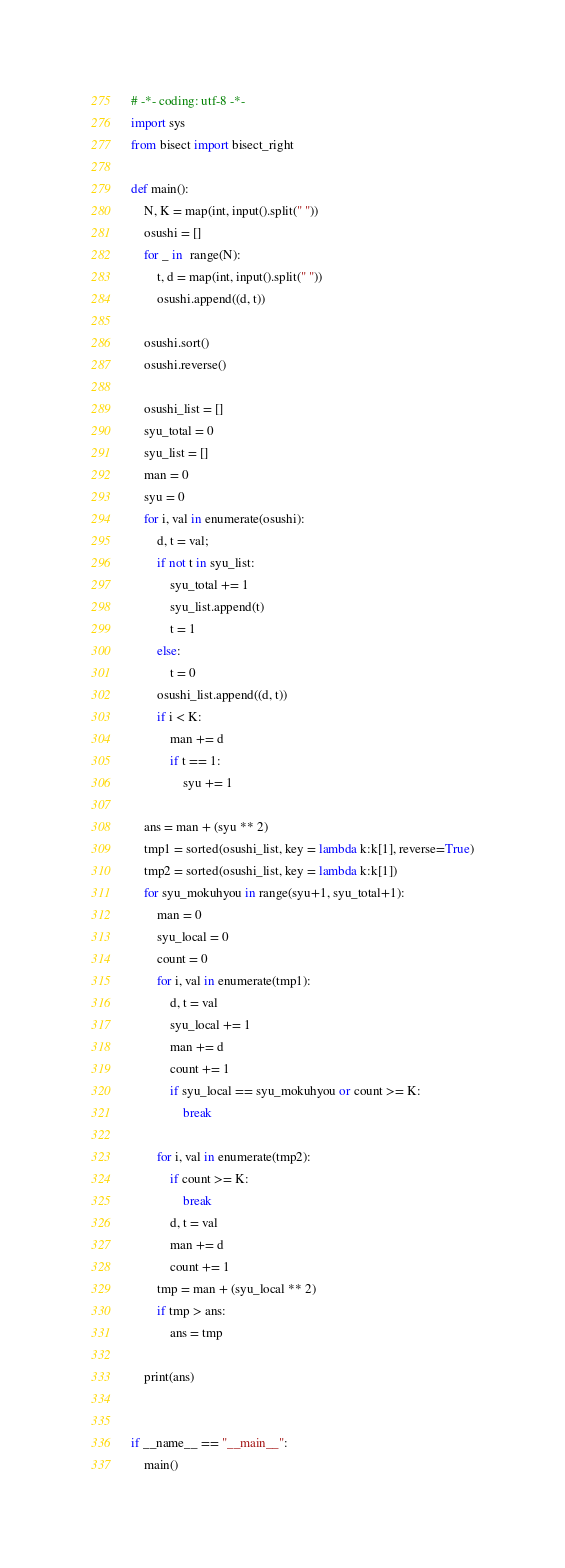<code> <loc_0><loc_0><loc_500><loc_500><_Python_># -*- coding: utf-8 -*-
import sys
from bisect import bisect_right

def main():
	N, K = map(int, input().split(" "))
	osushi = []
	for _ in  range(N):
		t, d = map(int, input().split(" "))
		osushi.append((d, t))
		
	osushi.sort()
	osushi.reverse()
	
	osushi_list = []
	syu_total = 0
	syu_list = []
	man = 0
	syu = 0
	for i, val in enumerate(osushi):
		d, t = val;
		if not t in syu_list:
			syu_total += 1
			syu_list.append(t)
			t = 1
		else:
			t = 0
		osushi_list.append((d, t))
		if i < K:
			man += d
			if t == 1:
				syu += 1
	
	ans = man + (syu ** 2)
	tmp1 = sorted(osushi_list, key = lambda k:k[1], reverse=True)
	tmp2 = sorted(osushi_list, key = lambda k:k[1])
	for syu_mokuhyou in range(syu+1, syu_total+1):
		man = 0
		syu_local = 0
		count = 0
		for i, val in enumerate(tmp1):
			d, t = val
			syu_local += 1
			man += d
			count += 1
			if syu_local == syu_mokuhyou or count >= K:
				break
					
		for i, val in enumerate(tmp2):
			if count >= K:
				break
			d, t = val
			man += d
			count += 1
		tmp = man + (syu_local ** 2)
		if tmp > ans:
			ans = tmp
		
	print(ans)
	
	
if __name__ == "__main__":
	main()
</code> 